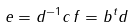<formula> <loc_0><loc_0><loc_500><loc_500>e = d ^ { - 1 } c \, f = b ^ { t } d</formula> 